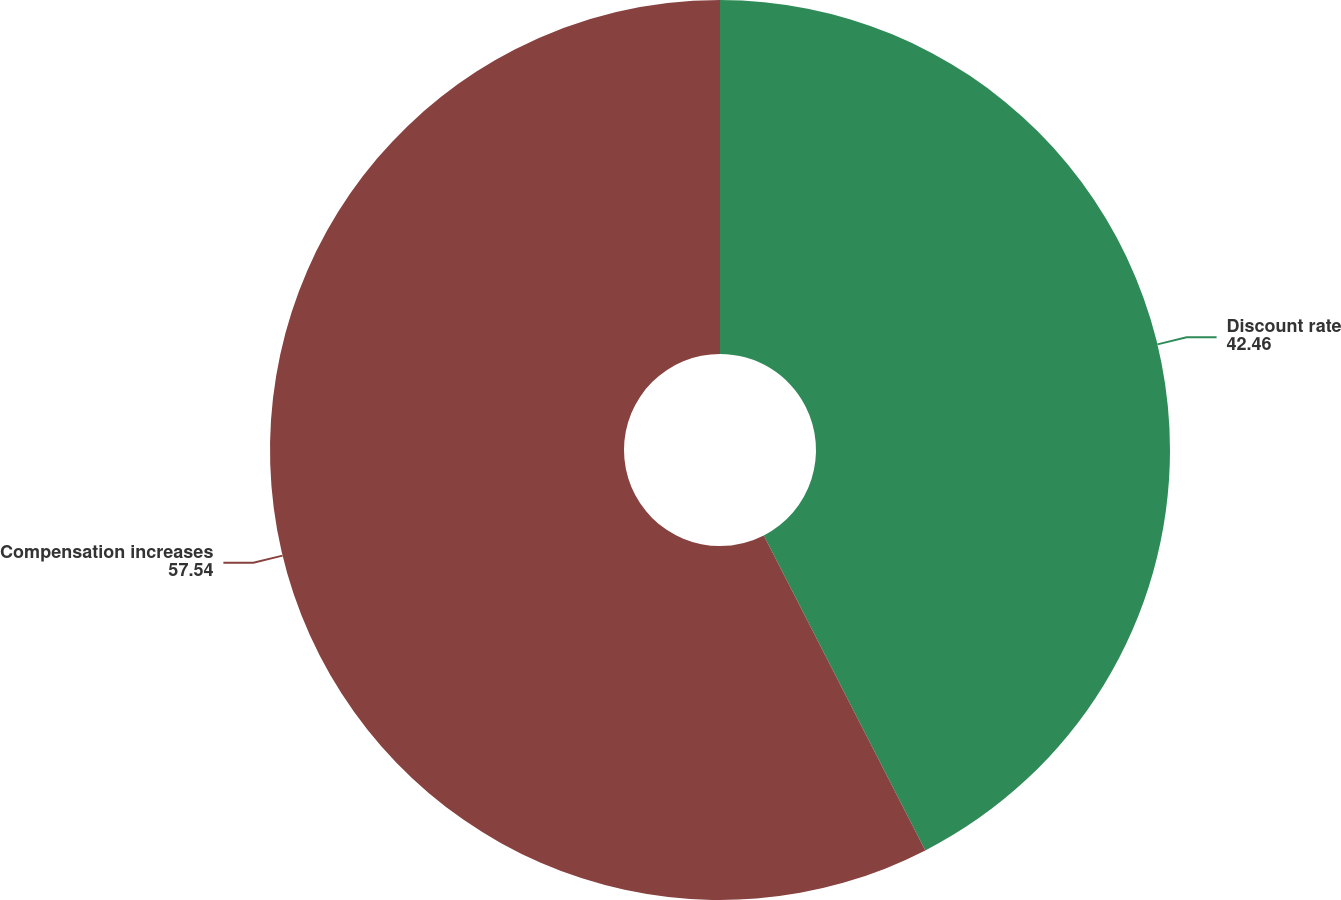Convert chart to OTSL. <chart><loc_0><loc_0><loc_500><loc_500><pie_chart><fcel>Discount rate<fcel>Compensation increases<nl><fcel>42.46%<fcel>57.54%<nl></chart> 